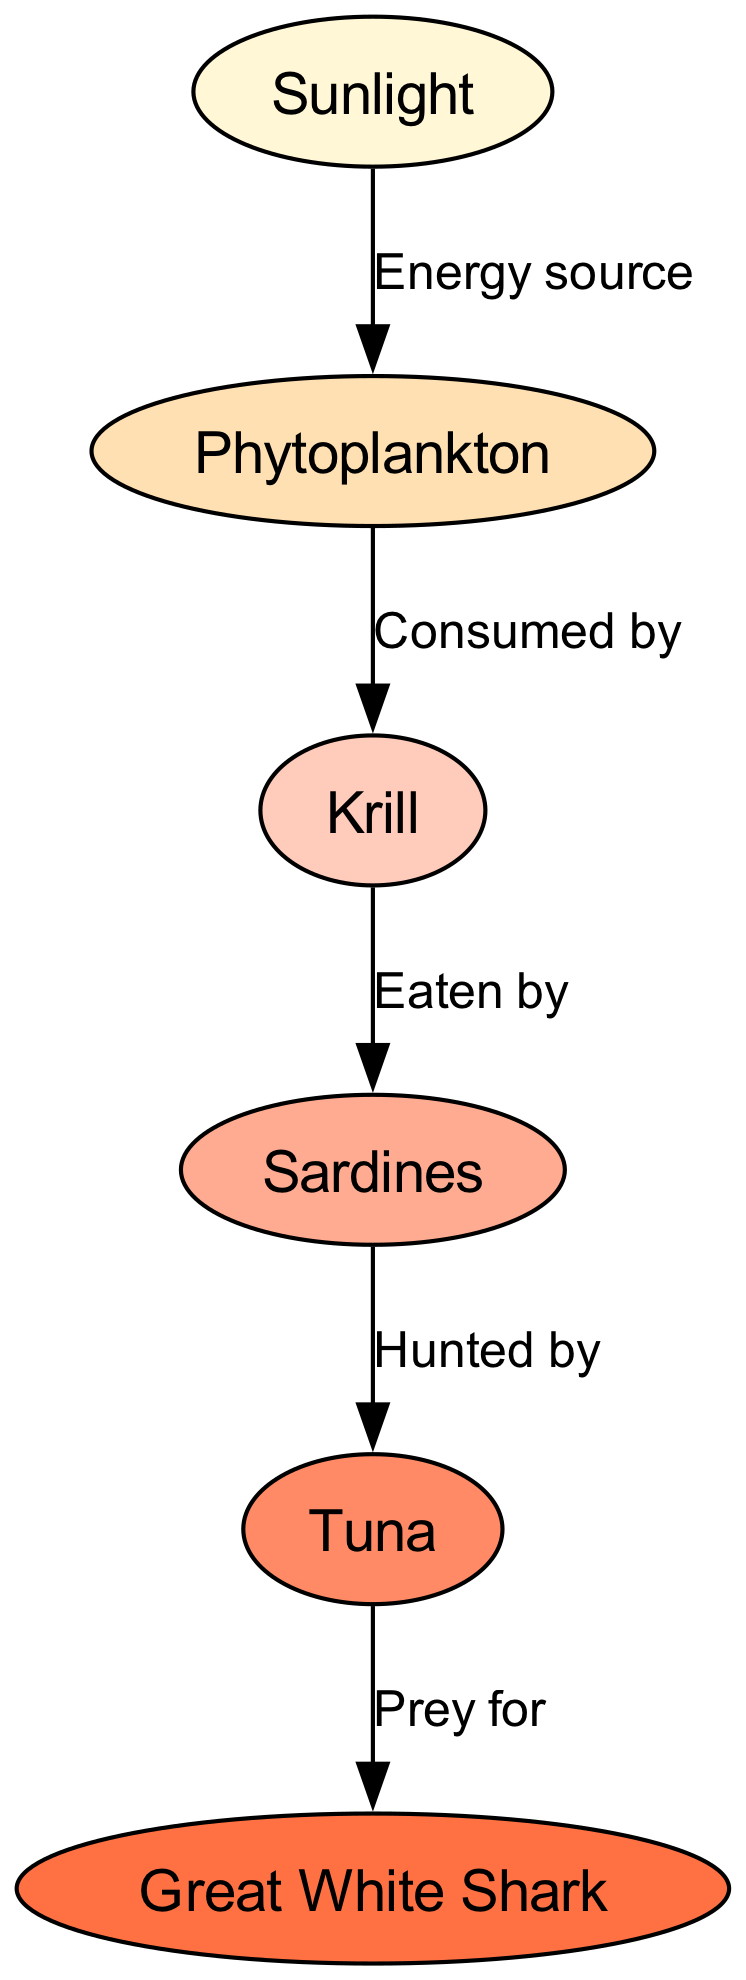What is the first node in the food chain? The first node in the food chain is related to the source of energy, which is represented by "Sunlight."
Answer: Sunlight How many nodes are in the diagram? By counting the different entities depicted in the diagram, we see there are six unique nodes representing various levels in the food chain.
Answer: 6 Which node is consumed by krill? The diagram indicates a direct flow from "Phytoplankton" to "Krill," meaning krill consumes phytoplankton.
Answer: Phytoplankton What do sardines hunt? Looking at the edges, sardines are indicated to be eaten by another node, specifically "Tuna," showing that sardines are the hunted species in this relationship.
Answer: Tuna Which node is the top predator in this food chain? Following the arrows visually, we see that "Great White Shark" has no outgoing edges, indicating it is not preyed upon by any other node, thus making it the apex predator in this chain.
Answer: Great White Shark What is the relationship between tuna and sharks? The edge connecting "Tuna" to "Great White Shark" is labeled "Prey for," defining the relationship where tuna serves as prey for the sharks.
Answer: Prey for What type of organism is "krill" in this food chain? Analyzing the structure of the food chain, "Krill" occupies a role as a primary consumer, as it directly feeds on phytoplankton, the primary producer.
Answer: Primary consumer How many edges are depicted in the ocean food chain? By counting the connections between the nodes, we find there are five directed edges indicating the flow of energy and predation within this food chain.
Answer: 5 What energy source fuels the phytoplankton? The diagram identifies "Sunlight" as the energy source upon which phytoplankton relies for photosynthesis and growth, making it essential in the food chain.
Answer: Sunlight 